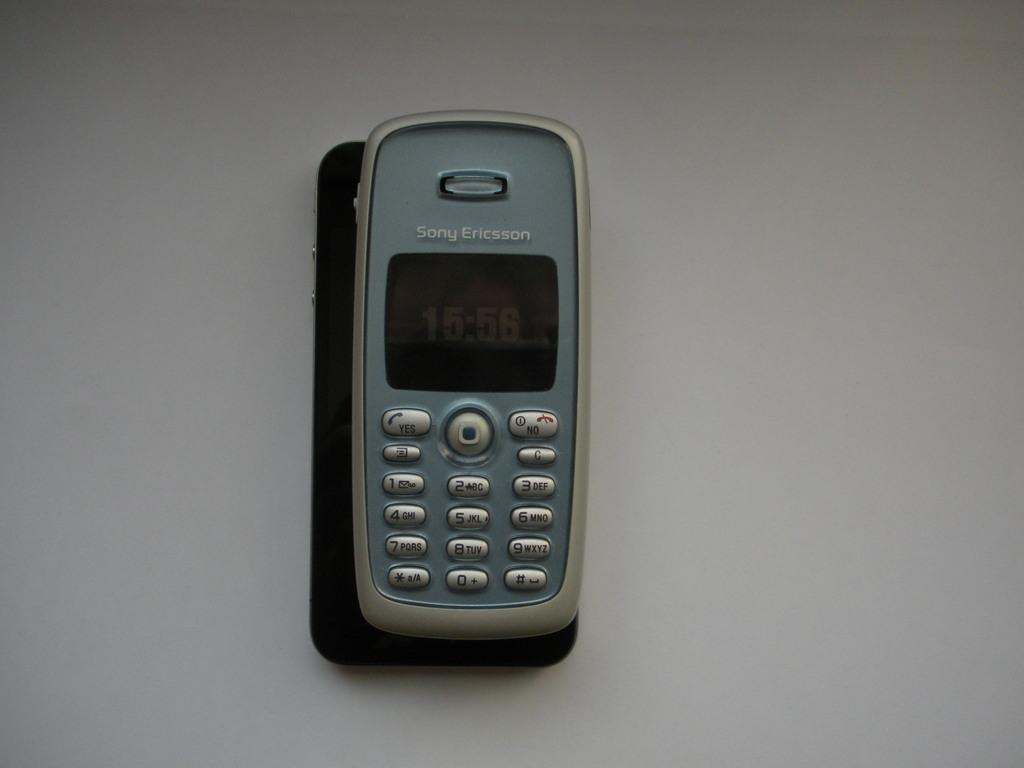Provide a one-sentence caption for the provided image. Old cellphone with the name Sony Ericsson on the top. 